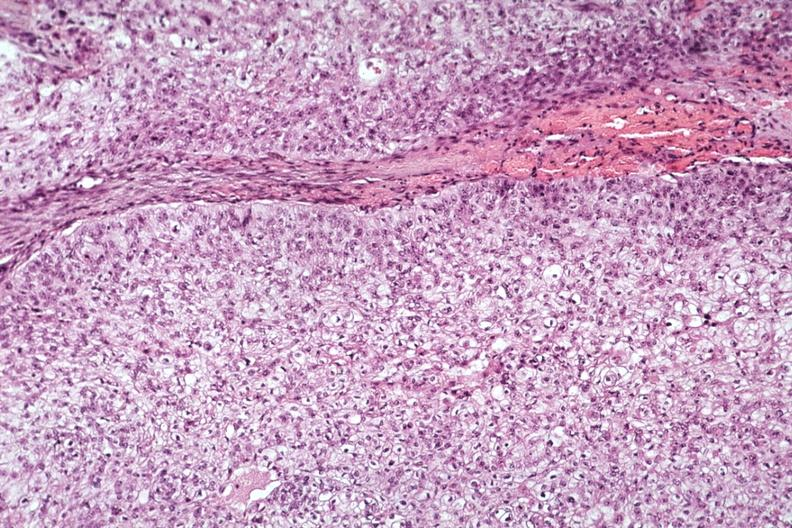s endocrine present?
Answer the question using a single word or phrase. Yes 